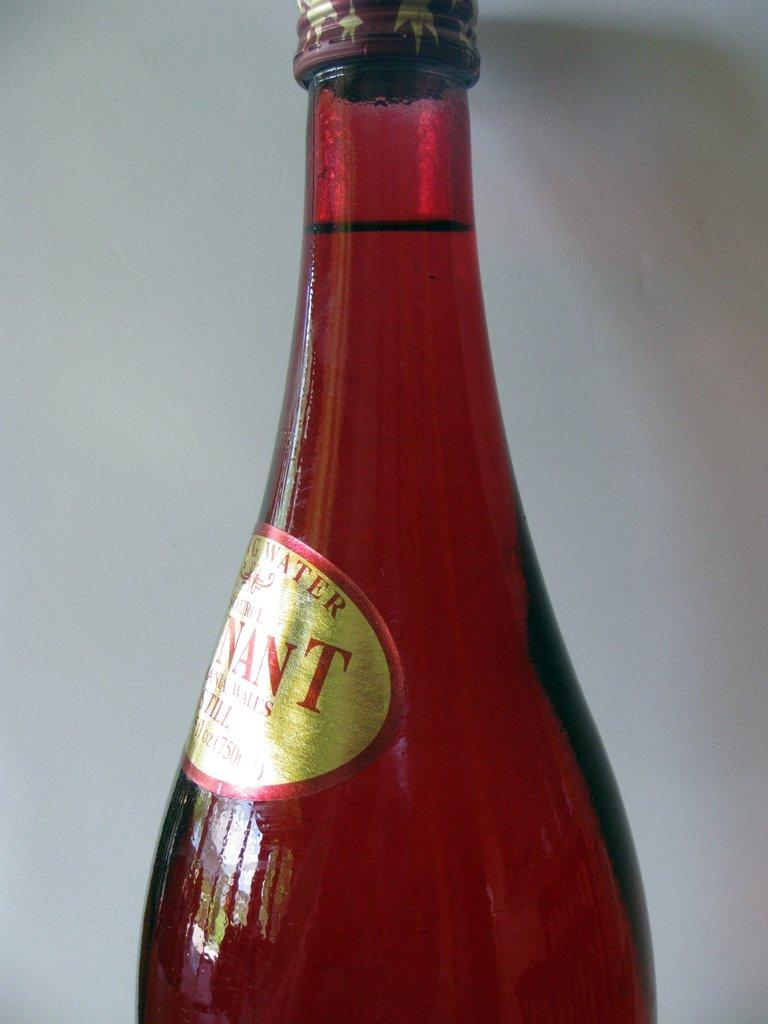<image>
Summarize the visual content of the image. A bottle has the partial word Nant on its sticker. 